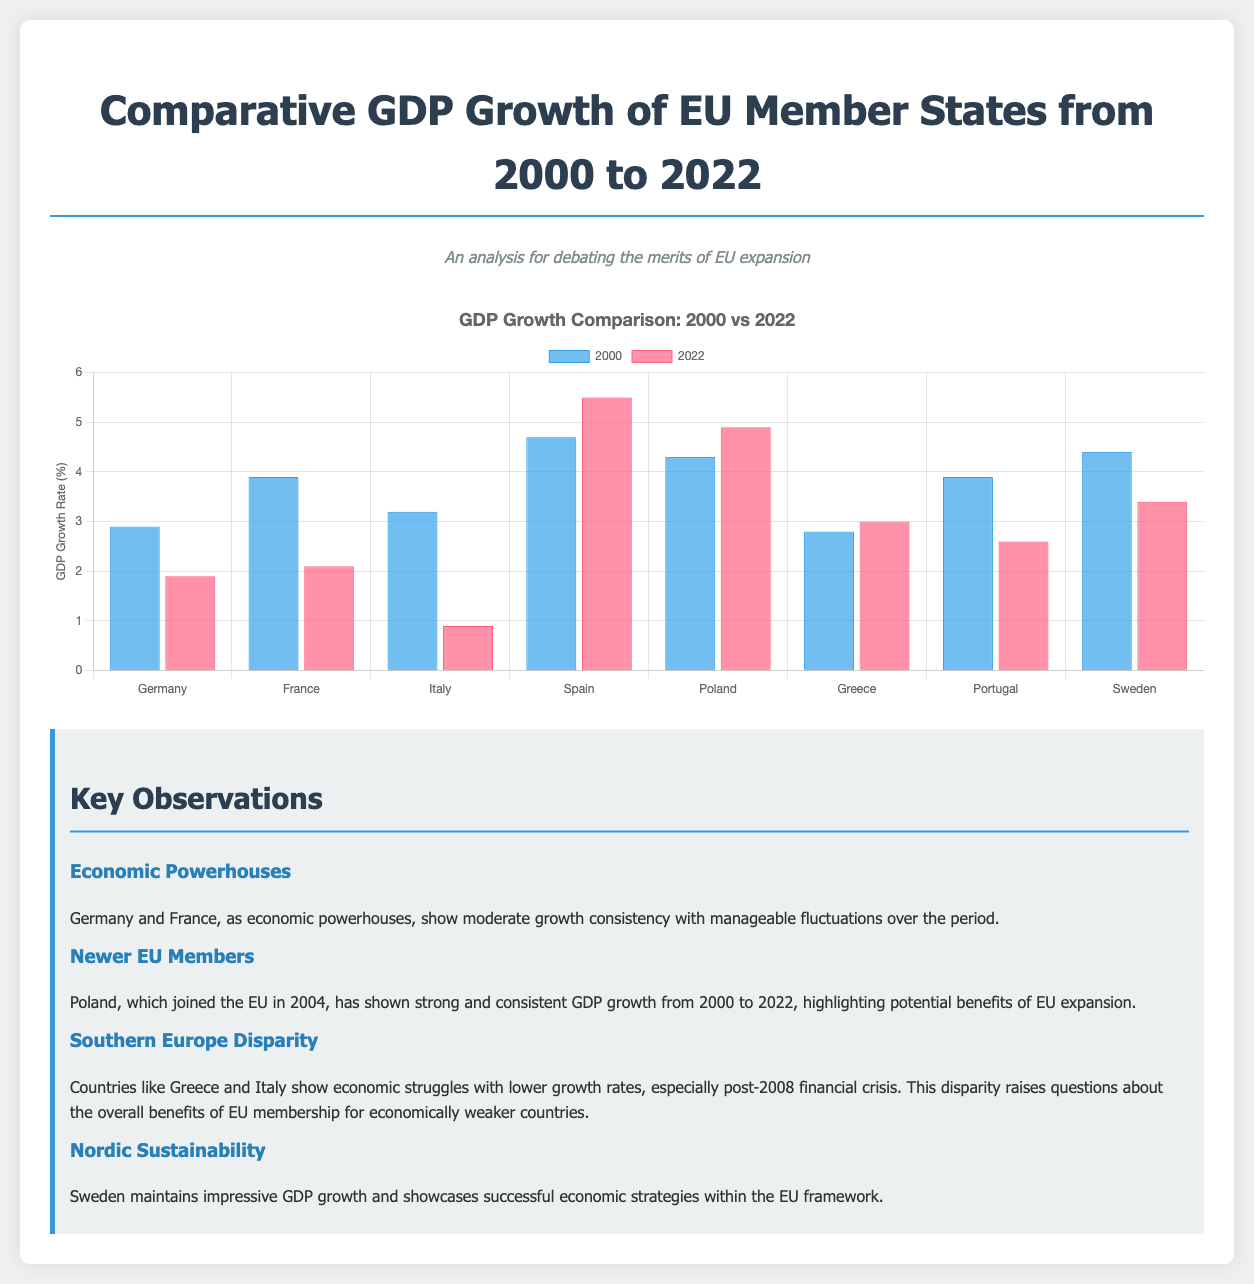What year did Poland join the EU? The document mentions that Poland joined the EU in 2004, highlighting its strong GDP growth since then.
Answer: 2004 Which country had the highest GDP growth rate in 2000? In the chart, Spain shows the highest GDP growth rate in the year 2000 at 4.7%.
Answer: 4.7% What is the GDP growth rate of Germany in 2022? The chart shows that Germany's GDP growth rate in 2022 is reported as 1.9%.
Answer: 1.9% Which country shows a significant GDP growth decrease from 2000 to 2022? The commentary notes that Italy shows lower growth rates, particularly post-2008 financial crisis, indicating a significant decrease in GDP growth.
Answer: Italy What can be inferred about the economic performance of Southern Europe? The commentary discusses economic struggles in Southern European countries, particularly highlighting lower growth rates in Greece and Italy, indicating significant disparities.
Answer: Disparities Which country maintained impressive GDP growth, according to the commentary? The commentary specifically mentions that Sweden showcases impressive GDP growth, attributed to successful economic strategies within the EU framework.
Answer: Sweden What does the chart compare? The chart compares GDP growth rates of selected EU member states for the years 2000 and 2022.
Answer: GDP growth rates How does France's GDP growth in 2022 compare to its growth in 2000? The comparison shows France's growth decreased from 3.9% in 2000 to 2.1% in 2022, indicating a decline over time.
Answer: Decline Which two countries are identified as economic powerhouses? The commentary identifies Germany and France as economic powerhouses indicating their consistent moderate growth.
Answer: Germany and France 